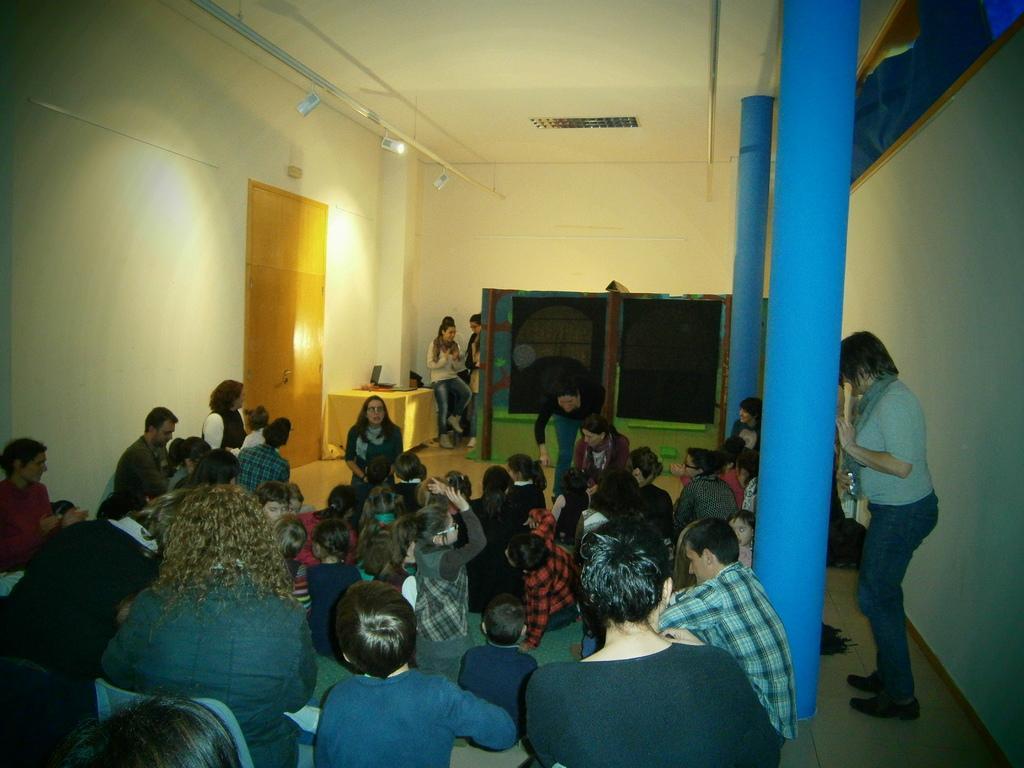Describe this image in one or two sentences. The picture is taken in a room. In the center of the picture there are kids, women and men. In the background there are lights, door, wall and women. On the right there are pillars and a woman. 